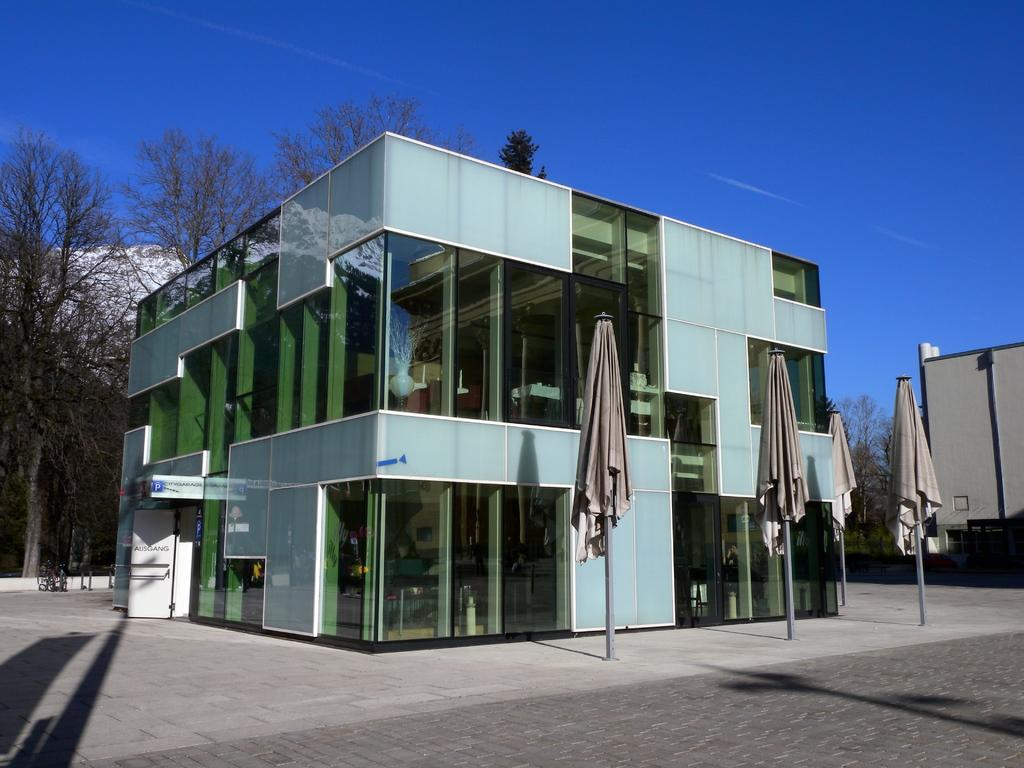What type of structure is present in the image? There is a building in the image. What feature can be observed on the building? The building has glass windows. What can be seen in the background of the image? There are poles and dried trees in the background of the image. What is visible at the top of the image? The sky is visible in the image. Can you see a donkey sitting on a cushion in the image? No, there is no donkey or cushion present in the image. 